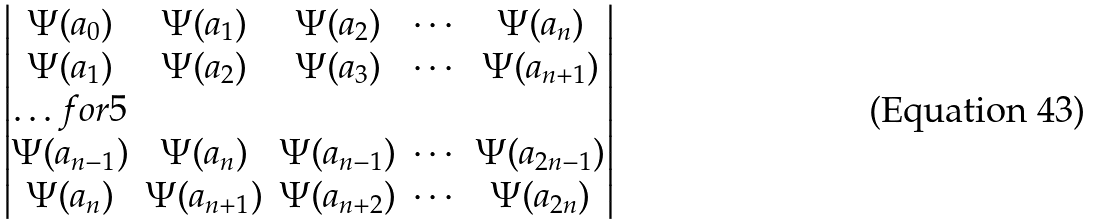<formula> <loc_0><loc_0><loc_500><loc_500>\begin{vmatrix} \Psi ( a _ { 0 } ) & \Psi ( a _ { 1 } ) & \Psi ( a _ { 2 } ) & \cdots & \Psi ( a _ { n } ) \\ \Psi ( a _ { 1 } ) & \Psi ( a _ { 2 } ) & \Psi ( a _ { 3 } ) & \cdots & \Psi ( a _ { n + 1 } ) \\ \hdots f o r { 5 } \\ \Psi ( a _ { n - 1 } ) & \Psi ( a _ { n } ) & \Psi ( a _ { n - 1 } ) & \cdots & \Psi ( a _ { 2 n - 1 } ) \\ \Psi ( a _ { n } ) & \Psi ( a _ { n + 1 } ) & \Psi ( a _ { n + 2 } ) & \cdots & \Psi ( a _ { 2 n } ) \end{vmatrix}</formula> 